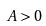Convert formula to latex. <formula><loc_0><loc_0><loc_500><loc_500>A > 0</formula> 